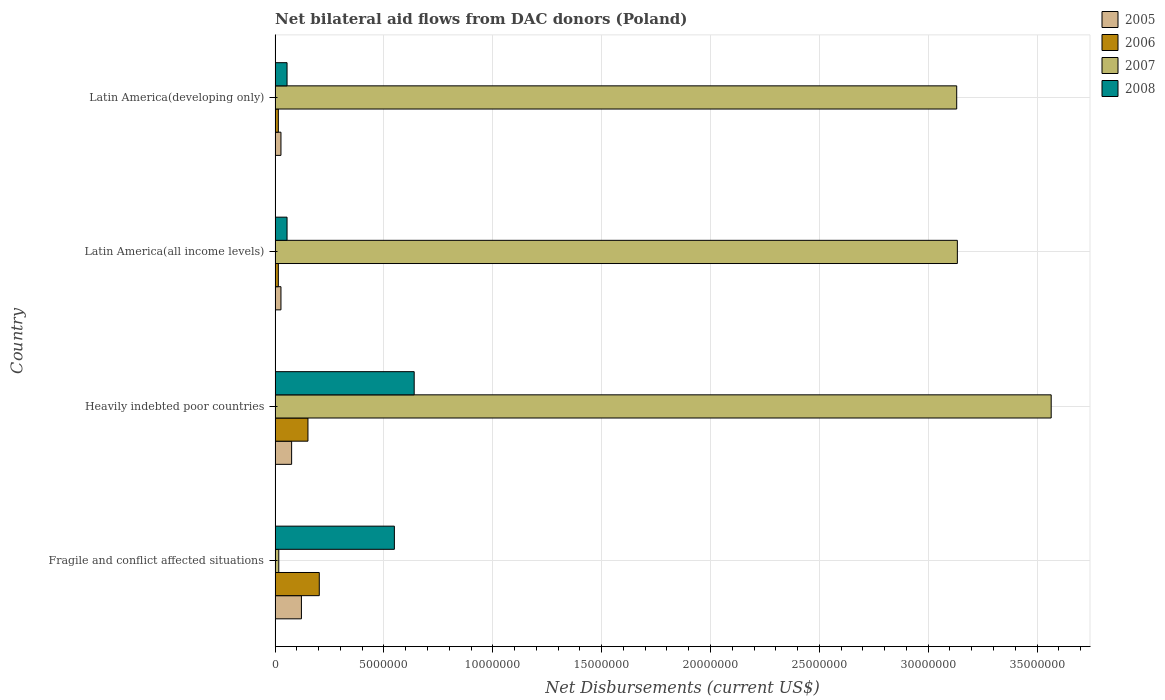How many different coloured bars are there?
Make the answer very short. 4. How many groups of bars are there?
Offer a very short reply. 4. Are the number of bars on each tick of the Y-axis equal?
Make the answer very short. Yes. How many bars are there on the 3rd tick from the top?
Offer a terse response. 4. How many bars are there on the 2nd tick from the bottom?
Provide a succinct answer. 4. What is the label of the 2nd group of bars from the top?
Make the answer very short. Latin America(all income levels). In how many cases, is the number of bars for a given country not equal to the number of legend labels?
Give a very brief answer. 0. What is the net bilateral aid flows in 2007 in Heavily indebted poor countries?
Your answer should be compact. 3.56e+07. Across all countries, what is the maximum net bilateral aid flows in 2007?
Offer a terse response. 3.56e+07. Across all countries, what is the minimum net bilateral aid flows in 2007?
Ensure brevity in your answer.  1.70e+05. In which country was the net bilateral aid flows in 2007 maximum?
Offer a very short reply. Heavily indebted poor countries. In which country was the net bilateral aid flows in 2005 minimum?
Your answer should be very brief. Latin America(all income levels). What is the total net bilateral aid flows in 2007 in the graph?
Keep it short and to the point. 9.85e+07. What is the difference between the net bilateral aid flows in 2008 in Fragile and conflict affected situations and that in Latin America(all income levels)?
Your answer should be very brief. 4.93e+06. What is the difference between the net bilateral aid flows in 2007 in Heavily indebted poor countries and the net bilateral aid flows in 2008 in Fragile and conflict affected situations?
Offer a very short reply. 3.02e+07. What is the average net bilateral aid flows in 2005 per country?
Keep it short and to the point. 6.28e+05. What is the difference between the net bilateral aid flows in 2006 and net bilateral aid flows in 2007 in Heavily indebted poor countries?
Make the answer very short. -3.41e+07. What is the ratio of the net bilateral aid flows in 2007 in Latin America(all income levels) to that in Latin America(developing only)?
Provide a short and direct response. 1. Is the net bilateral aid flows in 2008 in Fragile and conflict affected situations less than that in Latin America(developing only)?
Give a very brief answer. No. What is the difference between the highest and the second highest net bilateral aid flows in 2008?
Provide a short and direct response. 9.10e+05. What is the difference between the highest and the lowest net bilateral aid flows in 2007?
Make the answer very short. 3.55e+07. In how many countries, is the net bilateral aid flows in 2007 greater than the average net bilateral aid flows in 2007 taken over all countries?
Give a very brief answer. 3. What does the 4th bar from the bottom in Latin America(all income levels) represents?
Offer a terse response. 2008. Is it the case that in every country, the sum of the net bilateral aid flows in 2005 and net bilateral aid flows in 2008 is greater than the net bilateral aid flows in 2006?
Offer a very short reply. Yes. How many countries are there in the graph?
Give a very brief answer. 4. What is the difference between two consecutive major ticks on the X-axis?
Give a very brief answer. 5.00e+06. Does the graph contain any zero values?
Provide a short and direct response. No. Where does the legend appear in the graph?
Provide a succinct answer. Top right. How many legend labels are there?
Your answer should be compact. 4. How are the legend labels stacked?
Provide a short and direct response. Vertical. What is the title of the graph?
Provide a succinct answer. Net bilateral aid flows from DAC donors (Poland). What is the label or title of the X-axis?
Your response must be concise. Net Disbursements (current US$). What is the label or title of the Y-axis?
Keep it short and to the point. Country. What is the Net Disbursements (current US$) in 2005 in Fragile and conflict affected situations?
Provide a succinct answer. 1.21e+06. What is the Net Disbursements (current US$) of 2006 in Fragile and conflict affected situations?
Provide a succinct answer. 2.03e+06. What is the Net Disbursements (current US$) in 2008 in Fragile and conflict affected situations?
Ensure brevity in your answer.  5.48e+06. What is the Net Disbursements (current US$) of 2005 in Heavily indebted poor countries?
Ensure brevity in your answer.  7.60e+05. What is the Net Disbursements (current US$) in 2006 in Heavily indebted poor countries?
Provide a succinct answer. 1.51e+06. What is the Net Disbursements (current US$) in 2007 in Heavily indebted poor countries?
Offer a very short reply. 3.56e+07. What is the Net Disbursements (current US$) of 2008 in Heavily indebted poor countries?
Your response must be concise. 6.39e+06. What is the Net Disbursements (current US$) of 2005 in Latin America(all income levels)?
Your answer should be compact. 2.70e+05. What is the Net Disbursements (current US$) in 2006 in Latin America(all income levels)?
Your answer should be very brief. 1.50e+05. What is the Net Disbursements (current US$) of 2007 in Latin America(all income levels)?
Provide a short and direct response. 3.13e+07. What is the Net Disbursements (current US$) in 2008 in Latin America(all income levels)?
Offer a very short reply. 5.50e+05. What is the Net Disbursements (current US$) of 2007 in Latin America(developing only)?
Your answer should be compact. 3.13e+07. What is the Net Disbursements (current US$) in 2008 in Latin America(developing only)?
Ensure brevity in your answer.  5.50e+05. Across all countries, what is the maximum Net Disbursements (current US$) in 2005?
Your answer should be very brief. 1.21e+06. Across all countries, what is the maximum Net Disbursements (current US$) of 2006?
Ensure brevity in your answer.  2.03e+06. Across all countries, what is the maximum Net Disbursements (current US$) of 2007?
Your response must be concise. 3.56e+07. Across all countries, what is the maximum Net Disbursements (current US$) of 2008?
Your answer should be compact. 6.39e+06. Across all countries, what is the minimum Net Disbursements (current US$) of 2005?
Offer a very short reply. 2.70e+05. Across all countries, what is the minimum Net Disbursements (current US$) in 2006?
Provide a succinct answer. 1.50e+05. Across all countries, what is the minimum Net Disbursements (current US$) of 2007?
Ensure brevity in your answer.  1.70e+05. Across all countries, what is the minimum Net Disbursements (current US$) of 2008?
Make the answer very short. 5.50e+05. What is the total Net Disbursements (current US$) of 2005 in the graph?
Keep it short and to the point. 2.51e+06. What is the total Net Disbursements (current US$) in 2006 in the graph?
Provide a short and direct response. 3.84e+06. What is the total Net Disbursements (current US$) of 2007 in the graph?
Your answer should be very brief. 9.85e+07. What is the total Net Disbursements (current US$) in 2008 in the graph?
Keep it short and to the point. 1.30e+07. What is the difference between the Net Disbursements (current US$) in 2005 in Fragile and conflict affected situations and that in Heavily indebted poor countries?
Provide a short and direct response. 4.50e+05. What is the difference between the Net Disbursements (current US$) in 2006 in Fragile and conflict affected situations and that in Heavily indebted poor countries?
Ensure brevity in your answer.  5.20e+05. What is the difference between the Net Disbursements (current US$) in 2007 in Fragile and conflict affected situations and that in Heavily indebted poor countries?
Give a very brief answer. -3.55e+07. What is the difference between the Net Disbursements (current US$) in 2008 in Fragile and conflict affected situations and that in Heavily indebted poor countries?
Ensure brevity in your answer.  -9.10e+05. What is the difference between the Net Disbursements (current US$) of 2005 in Fragile and conflict affected situations and that in Latin America(all income levels)?
Provide a short and direct response. 9.40e+05. What is the difference between the Net Disbursements (current US$) of 2006 in Fragile and conflict affected situations and that in Latin America(all income levels)?
Keep it short and to the point. 1.88e+06. What is the difference between the Net Disbursements (current US$) of 2007 in Fragile and conflict affected situations and that in Latin America(all income levels)?
Your answer should be very brief. -3.12e+07. What is the difference between the Net Disbursements (current US$) of 2008 in Fragile and conflict affected situations and that in Latin America(all income levels)?
Keep it short and to the point. 4.93e+06. What is the difference between the Net Disbursements (current US$) of 2005 in Fragile and conflict affected situations and that in Latin America(developing only)?
Give a very brief answer. 9.40e+05. What is the difference between the Net Disbursements (current US$) of 2006 in Fragile and conflict affected situations and that in Latin America(developing only)?
Provide a succinct answer. 1.88e+06. What is the difference between the Net Disbursements (current US$) in 2007 in Fragile and conflict affected situations and that in Latin America(developing only)?
Provide a succinct answer. -3.11e+07. What is the difference between the Net Disbursements (current US$) of 2008 in Fragile and conflict affected situations and that in Latin America(developing only)?
Your answer should be very brief. 4.93e+06. What is the difference between the Net Disbursements (current US$) of 2006 in Heavily indebted poor countries and that in Latin America(all income levels)?
Give a very brief answer. 1.36e+06. What is the difference between the Net Disbursements (current US$) in 2007 in Heavily indebted poor countries and that in Latin America(all income levels)?
Provide a succinct answer. 4.31e+06. What is the difference between the Net Disbursements (current US$) of 2008 in Heavily indebted poor countries and that in Latin America(all income levels)?
Provide a short and direct response. 5.84e+06. What is the difference between the Net Disbursements (current US$) of 2006 in Heavily indebted poor countries and that in Latin America(developing only)?
Offer a very short reply. 1.36e+06. What is the difference between the Net Disbursements (current US$) in 2007 in Heavily indebted poor countries and that in Latin America(developing only)?
Your response must be concise. 4.34e+06. What is the difference between the Net Disbursements (current US$) in 2008 in Heavily indebted poor countries and that in Latin America(developing only)?
Make the answer very short. 5.84e+06. What is the difference between the Net Disbursements (current US$) in 2006 in Latin America(all income levels) and that in Latin America(developing only)?
Your response must be concise. 0. What is the difference between the Net Disbursements (current US$) in 2007 in Latin America(all income levels) and that in Latin America(developing only)?
Provide a succinct answer. 3.00e+04. What is the difference between the Net Disbursements (current US$) of 2008 in Latin America(all income levels) and that in Latin America(developing only)?
Keep it short and to the point. 0. What is the difference between the Net Disbursements (current US$) of 2005 in Fragile and conflict affected situations and the Net Disbursements (current US$) of 2007 in Heavily indebted poor countries?
Your answer should be compact. -3.44e+07. What is the difference between the Net Disbursements (current US$) in 2005 in Fragile and conflict affected situations and the Net Disbursements (current US$) in 2008 in Heavily indebted poor countries?
Your answer should be very brief. -5.18e+06. What is the difference between the Net Disbursements (current US$) in 2006 in Fragile and conflict affected situations and the Net Disbursements (current US$) in 2007 in Heavily indebted poor countries?
Make the answer very short. -3.36e+07. What is the difference between the Net Disbursements (current US$) in 2006 in Fragile and conflict affected situations and the Net Disbursements (current US$) in 2008 in Heavily indebted poor countries?
Ensure brevity in your answer.  -4.36e+06. What is the difference between the Net Disbursements (current US$) of 2007 in Fragile and conflict affected situations and the Net Disbursements (current US$) of 2008 in Heavily indebted poor countries?
Offer a terse response. -6.22e+06. What is the difference between the Net Disbursements (current US$) in 2005 in Fragile and conflict affected situations and the Net Disbursements (current US$) in 2006 in Latin America(all income levels)?
Give a very brief answer. 1.06e+06. What is the difference between the Net Disbursements (current US$) of 2005 in Fragile and conflict affected situations and the Net Disbursements (current US$) of 2007 in Latin America(all income levels)?
Ensure brevity in your answer.  -3.01e+07. What is the difference between the Net Disbursements (current US$) of 2006 in Fragile and conflict affected situations and the Net Disbursements (current US$) of 2007 in Latin America(all income levels)?
Give a very brief answer. -2.93e+07. What is the difference between the Net Disbursements (current US$) of 2006 in Fragile and conflict affected situations and the Net Disbursements (current US$) of 2008 in Latin America(all income levels)?
Offer a very short reply. 1.48e+06. What is the difference between the Net Disbursements (current US$) of 2007 in Fragile and conflict affected situations and the Net Disbursements (current US$) of 2008 in Latin America(all income levels)?
Provide a short and direct response. -3.80e+05. What is the difference between the Net Disbursements (current US$) in 2005 in Fragile and conflict affected situations and the Net Disbursements (current US$) in 2006 in Latin America(developing only)?
Ensure brevity in your answer.  1.06e+06. What is the difference between the Net Disbursements (current US$) of 2005 in Fragile and conflict affected situations and the Net Disbursements (current US$) of 2007 in Latin America(developing only)?
Your answer should be very brief. -3.01e+07. What is the difference between the Net Disbursements (current US$) in 2005 in Fragile and conflict affected situations and the Net Disbursements (current US$) in 2008 in Latin America(developing only)?
Give a very brief answer. 6.60e+05. What is the difference between the Net Disbursements (current US$) in 2006 in Fragile and conflict affected situations and the Net Disbursements (current US$) in 2007 in Latin America(developing only)?
Ensure brevity in your answer.  -2.93e+07. What is the difference between the Net Disbursements (current US$) of 2006 in Fragile and conflict affected situations and the Net Disbursements (current US$) of 2008 in Latin America(developing only)?
Offer a terse response. 1.48e+06. What is the difference between the Net Disbursements (current US$) of 2007 in Fragile and conflict affected situations and the Net Disbursements (current US$) of 2008 in Latin America(developing only)?
Your response must be concise. -3.80e+05. What is the difference between the Net Disbursements (current US$) of 2005 in Heavily indebted poor countries and the Net Disbursements (current US$) of 2006 in Latin America(all income levels)?
Your answer should be very brief. 6.10e+05. What is the difference between the Net Disbursements (current US$) in 2005 in Heavily indebted poor countries and the Net Disbursements (current US$) in 2007 in Latin America(all income levels)?
Your answer should be very brief. -3.06e+07. What is the difference between the Net Disbursements (current US$) in 2006 in Heavily indebted poor countries and the Net Disbursements (current US$) in 2007 in Latin America(all income levels)?
Ensure brevity in your answer.  -2.98e+07. What is the difference between the Net Disbursements (current US$) in 2006 in Heavily indebted poor countries and the Net Disbursements (current US$) in 2008 in Latin America(all income levels)?
Ensure brevity in your answer.  9.60e+05. What is the difference between the Net Disbursements (current US$) in 2007 in Heavily indebted poor countries and the Net Disbursements (current US$) in 2008 in Latin America(all income levels)?
Your response must be concise. 3.51e+07. What is the difference between the Net Disbursements (current US$) of 2005 in Heavily indebted poor countries and the Net Disbursements (current US$) of 2006 in Latin America(developing only)?
Ensure brevity in your answer.  6.10e+05. What is the difference between the Net Disbursements (current US$) in 2005 in Heavily indebted poor countries and the Net Disbursements (current US$) in 2007 in Latin America(developing only)?
Your answer should be compact. -3.06e+07. What is the difference between the Net Disbursements (current US$) in 2005 in Heavily indebted poor countries and the Net Disbursements (current US$) in 2008 in Latin America(developing only)?
Your answer should be compact. 2.10e+05. What is the difference between the Net Disbursements (current US$) in 2006 in Heavily indebted poor countries and the Net Disbursements (current US$) in 2007 in Latin America(developing only)?
Keep it short and to the point. -2.98e+07. What is the difference between the Net Disbursements (current US$) in 2006 in Heavily indebted poor countries and the Net Disbursements (current US$) in 2008 in Latin America(developing only)?
Your answer should be compact. 9.60e+05. What is the difference between the Net Disbursements (current US$) in 2007 in Heavily indebted poor countries and the Net Disbursements (current US$) in 2008 in Latin America(developing only)?
Your answer should be very brief. 3.51e+07. What is the difference between the Net Disbursements (current US$) in 2005 in Latin America(all income levels) and the Net Disbursements (current US$) in 2007 in Latin America(developing only)?
Your answer should be very brief. -3.10e+07. What is the difference between the Net Disbursements (current US$) of 2005 in Latin America(all income levels) and the Net Disbursements (current US$) of 2008 in Latin America(developing only)?
Your response must be concise. -2.80e+05. What is the difference between the Net Disbursements (current US$) in 2006 in Latin America(all income levels) and the Net Disbursements (current US$) in 2007 in Latin America(developing only)?
Provide a succinct answer. -3.12e+07. What is the difference between the Net Disbursements (current US$) of 2006 in Latin America(all income levels) and the Net Disbursements (current US$) of 2008 in Latin America(developing only)?
Give a very brief answer. -4.00e+05. What is the difference between the Net Disbursements (current US$) in 2007 in Latin America(all income levels) and the Net Disbursements (current US$) in 2008 in Latin America(developing only)?
Your answer should be very brief. 3.08e+07. What is the average Net Disbursements (current US$) in 2005 per country?
Your answer should be compact. 6.28e+05. What is the average Net Disbursements (current US$) in 2006 per country?
Offer a terse response. 9.60e+05. What is the average Net Disbursements (current US$) in 2007 per country?
Provide a short and direct response. 2.46e+07. What is the average Net Disbursements (current US$) of 2008 per country?
Offer a very short reply. 3.24e+06. What is the difference between the Net Disbursements (current US$) of 2005 and Net Disbursements (current US$) of 2006 in Fragile and conflict affected situations?
Your response must be concise. -8.20e+05. What is the difference between the Net Disbursements (current US$) of 2005 and Net Disbursements (current US$) of 2007 in Fragile and conflict affected situations?
Your answer should be very brief. 1.04e+06. What is the difference between the Net Disbursements (current US$) in 2005 and Net Disbursements (current US$) in 2008 in Fragile and conflict affected situations?
Ensure brevity in your answer.  -4.27e+06. What is the difference between the Net Disbursements (current US$) of 2006 and Net Disbursements (current US$) of 2007 in Fragile and conflict affected situations?
Your answer should be very brief. 1.86e+06. What is the difference between the Net Disbursements (current US$) of 2006 and Net Disbursements (current US$) of 2008 in Fragile and conflict affected situations?
Ensure brevity in your answer.  -3.45e+06. What is the difference between the Net Disbursements (current US$) of 2007 and Net Disbursements (current US$) of 2008 in Fragile and conflict affected situations?
Your answer should be compact. -5.31e+06. What is the difference between the Net Disbursements (current US$) in 2005 and Net Disbursements (current US$) in 2006 in Heavily indebted poor countries?
Make the answer very short. -7.50e+05. What is the difference between the Net Disbursements (current US$) in 2005 and Net Disbursements (current US$) in 2007 in Heavily indebted poor countries?
Give a very brief answer. -3.49e+07. What is the difference between the Net Disbursements (current US$) in 2005 and Net Disbursements (current US$) in 2008 in Heavily indebted poor countries?
Offer a terse response. -5.63e+06. What is the difference between the Net Disbursements (current US$) of 2006 and Net Disbursements (current US$) of 2007 in Heavily indebted poor countries?
Keep it short and to the point. -3.41e+07. What is the difference between the Net Disbursements (current US$) of 2006 and Net Disbursements (current US$) of 2008 in Heavily indebted poor countries?
Your answer should be compact. -4.88e+06. What is the difference between the Net Disbursements (current US$) of 2007 and Net Disbursements (current US$) of 2008 in Heavily indebted poor countries?
Provide a succinct answer. 2.93e+07. What is the difference between the Net Disbursements (current US$) of 2005 and Net Disbursements (current US$) of 2007 in Latin America(all income levels)?
Ensure brevity in your answer.  -3.11e+07. What is the difference between the Net Disbursements (current US$) of 2005 and Net Disbursements (current US$) of 2008 in Latin America(all income levels)?
Your response must be concise. -2.80e+05. What is the difference between the Net Disbursements (current US$) of 2006 and Net Disbursements (current US$) of 2007 in Latin America(all income levels)?
Provide a succinct answer. -3.12e+07. What is the difference between the Net Disbursements (current US$) in 2006 and Net Disbursements (current US$) in 2008 in Latin America(all income levels)?
Make the answer very short. -4.00e+05. What is the difference between the Net Disbursements (current US$) of 2007 and Net Disbursements (current US$) of 2008 in Latin America(all income levels)?
Give a very brief answer. 3.08e+07. What is the difference between the Net Disbursements (current US$) in 2005 and Net Disbursements (current US$) in 2007 in Latin America(developing only)?
Give a very brief answer. -3.10e+07. What is the difference between the Net Disbursements (current US$) in 2005 and Net Disbursements (current US$) in 2008 in Latin America(developing only)?
Offer a very short reply. -2.80e+05. What is the difference between the Net Disbursements (current US$) in 2006 and Net Disbursements (current US$) in 2007 in Latin America(developing only)?
Offer a terse response. -3.12e+07. What is the difference between the Net Disbursements (current US$) of 2006 and Net Disbursements (current US$) of 2008 in Latin America(developing only)?
Your response must be concise. -4.00e+05. What is the difference between the Net Disbursements (current US$) of 2007 and Net Disbursements (current US$) of 2008 in Latin America(developing only)?
Give a very brief answer. 3.08e+07. What is the ratio of the Net Disbursements (current US$) of 2005 in Fragile and conflict affected situations to that in Heavily indebted poor countries?
Make the answer very short. 1.59. What is the ratio of the Net Disbursements (current US$) of 2006 in Fragile and conflict affected situations to that in Heavily indebted poor countries?
Provide a succinct answer. 1.34. What is the ratio of the Net Disbursements (current US$) in 2007 in Fragile and conflict affected situations to that in Heavily indebted poor countries?
Offer a terse response. 0. What is the ratio of the Net Disbursements (current US$) of 2008 in Fragile and conflict affected situations to that in Heavily indebted poor countries?
Provide a succinct answer. 0.86. What is the ratio of the Net Disbursements (current US$) in 2005 in Fragile and conflict affected situations to that in Latin America(all income levels)?
Provide a succinct answer. 4.48. What is the ratio of the Net Disbursements (current US$) of 2006 in Fragile and conflict affected situations to that in Latin America(all income levels)?
Keep it short and to the point. 13.53. What is the ratio of the Net Disbursements (current US$) of 2007 in Fragile and conflict affected situations to that in Latin America(all income levels)?
Offer a terse response. 0.01. What is the ratio of the Net Disbursements (current US$) of 2008 in Fragile and conflict affected situations to that in Latin America(all income levels)?
Provide a short and direct response. 9.96. What is the ratio of the Net Disbursements (current US$) in 2005 in Fragile and conflict affected situations to that in Latin America(developing only)?
Provide a short and direct response. 4.48. What is the ratio of the Net Disbursements (current US$) of 2006 in Fragile and conflict affected situations to that in Latin America(developing only)?
Your answer should be very brief. 13.53. What is the ratio of the Net Disbursements (current US$) in 2007 in Fragile and conflict affected situations to that in Latin America(developing only)?
Offer a very short reply. 0.01. What is the ratio of the Net Disbursements (current US$) in 2008 in Fragile and conflict affected situations to that in Latin America(developing only)?
Provide a succinct answer. 9.96. What is the ratio of the Net Disbursements (current US$) in 2005 in Heavily indebted poor countries to that in Latin America(all income levels)?
Provide a short and direct response. 2.81. What is the ratio of the Net Disbursements (current US$) in 2006 in Heavily indebted poor countries to that in Latin America(all income levels)?
Give a very brief answer. 10.07. What is the ratio of the Net Disbursements (current US$) of 2007 in Heavily indebted poor countries to that in Latin America(all income levels)?
Provide a succinct answer. 1.14. What is the ratio of the Net Disbursements (current US$) in 2008 in Heavily indebted poor countries to that in Latin America(all income levels)?
Ensure brevity in your answer.  11.62. What is the ratio of the Net Disbursements (current US$) of 2005 in Heavily indebted poor countries to that in Latin America(developing only)?
Your answer should be very brief. 2.81. What is the ratio of the Net Disbursements (current US$) of 2006 in Heavily indebted poor countries to that in Latin America(developing only)?
Ensure brevity in your answer.  10.07. What is the ratio of the Net Disbursements (current US$) of 2007 in Heavily indebted poor countries to that in Latin America(developing only)?
Your answer should be very brief. 1.14. What is the ratio of the Net Disbursements (current US$) of 2008 in Heavily indebted poor countries to that in Latin America(developing only)?
Provide a short and direct response. 11.62. What is the ratio of the Net Disbursements (current US$) in 2005 in Latin America(all income levels) to that in Latin America(developing only)?
Provide a succinct answer. 1. What is the ratio of the Net Disbursements (current US$) of 2006 in Latin America(all income levels) to that in Latin America(developing only)?
Offer a terse response. 1. What is the difference between the highest and the second highest Net Disbursements (current US$) in 2006?
Your answer should be very brief. 5.20e+05. What is the difference between the highest and the second highest Net Disbursements (current US$) in 2007?
Give a very brief answer. 4.31e+06. What is the difference between the highest and the second highest Net Disbursements (current US$) in 2008?
Ensure brevity in your answer.  9.10e+05. What is the difference between the highest and the lowest Net Disbursements (current US$) of 2005?
Ensure brevity in your answer.  9.40e+05. What is the difference between the highest and the lowest Net Disbursements (current US$) in 2006?
Give a very brief answer. 1.88e+06. What is the difference between the highest and the lowest Net Disbursements (current US$) of 2007?
Your answer should be very brief. 3.55e+07. What is the difference between the highest and the lowest Net Disbursements (current US$) in 2008?
Provide a short and direct response. 5.84e+06. 